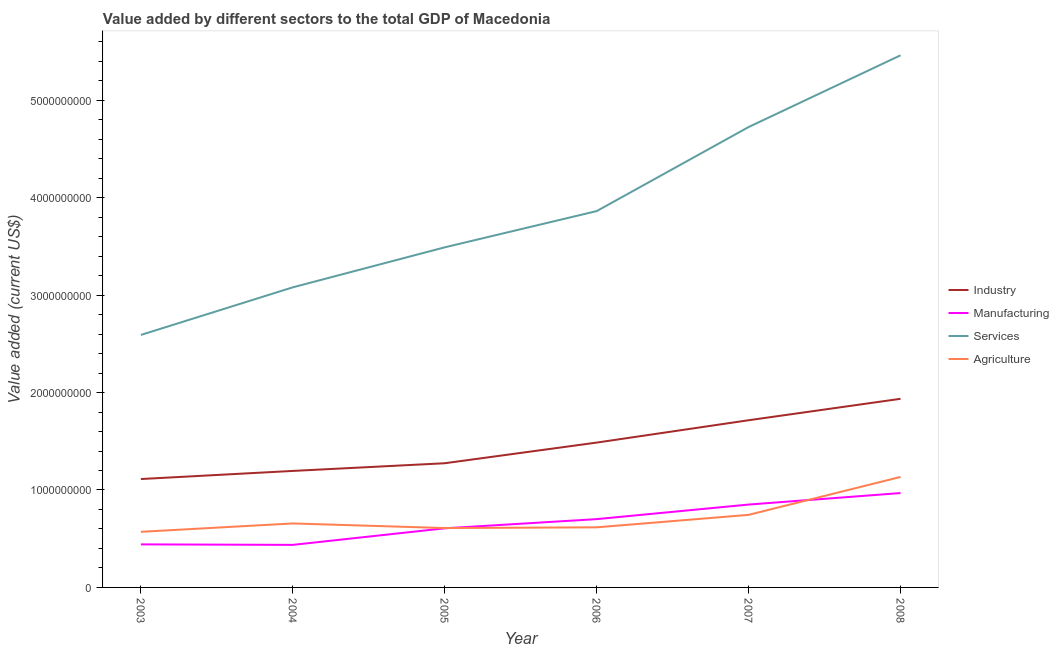How many different coloured lines are there?
Your answer should be compact. 4. Does the line corresponding to value added by agricultural sector intersect with the line corresponding to value added by industrial sector?
Your response must be concise. No. Is the number of lines equal to the number of legend labels?
Offer a very short reply. Yes. What is the value added by services sector in 2006?
Ensure brevity in your answer.  3.86e+09. Across all years, what is the maximum value added by industrial sector?
Provide a short and direct response. 1.94e+09. Across all years, what is the minimum value added by manufacturing sector?
Give a very brief answer. 4.37e+08. In which year was the value added by services sector maximum?
Offer a terse response. 2008. In which year was the value added by services sector minimum?
Make the answer very short. 2003. What is the total value added by services sector in the graph?
Give a very brief answer. 2.32e+1. What is the difference between the value added by services sector in 2007 and that in 2008?
Ensure brevity in your answer.  -7.36e+08. What is the difference between the value added by services sector in 2005 and the value added by manufacturing sector in 2003?
Offer a very short reply. 3.05e+09. What is the average value added by agricultural sector per year?
Your response must be concise. 7.22e+08. In the year 2004, what is the difference between the value added by manufacturing sector and value added by agricultural sector?
Your response must be concise. -2.20e+08. In how many years, is the value added by manufacturing sector greater than 600000000 US$?
Offer a terse response. 4. What is the ratio of the value added by manufacturing sector in 2004 to that in 2005?
Give a very brief answer. 0.72. Is the value added by industrial sector in 2006 less than that in 2008?
Make the answer very short. Yes. Is the difference between the value added by industrial sector in 2003 and 2007 greater than the difference between the value added by agricultural sector in 2003 and 2007?
Give a very brief answer. No. What is the difference between the highest and the second highest value added by agricultural sector?
Your answer should be very brief. 3.89e+08. What is the difference between the highest and the lowest value added by agricultural sector?
Keep it short and to the point. 5.63e+08. Is the sum of the value added by manufacturing sector in 2003 and 2008 greater than the maximum value added by services sector across all years?
Offer a terse response. No. Is it the case that in every year, the sum of the value added by industrial sector and value added by manufacturing sector is greater than the sum of value added by services sector and value added by agricultural sector?
Offer a terse response. Yes. Is it the case that in every year, the sum of the value added by industrial sector and value added by manufacturing sector is greater than the value added by services sector?
Provide a short and direct response. No. Is the value added by services sector strictly greater than the value added by agricultural sector over the years?
Your response must be concise. Yes. Is the value added by services sector strictly less than the value added by agricultural sector over the years?
Your answer should be very brief. No. How many lines are there?
Give a very brief answer. 4. Are the values on the major ticks of Y-axis written in scientific E-notation?
Give a very brief answer. No. What is the title of the graph?
Offer a very short reply. Value added by different sectors to the total GDP of Macedonia. Does "Tracking ability" appear as one of the legend labels in the graph?
Your answer should be compact. No. What is the label or title of the X-axis?
Provide a succinct answer. Year. What is the label or title of the Y-axis?
Your answer should be compact. Value added (current US$). What is the Value added (current US$) in Industry in 2003?
Your answer should be compact. 1.11e+09. What is the Value added (current US$) in Manufacturing in 2003?
Your answer should be very brief. 4.42e+08. What is the Value added (current US$) in Services in 2003?
Your response must be concise. 2.59e+09. What is the Value added (current US$) in Agriculture in 2003?
Give a very brief answer. 5.71e+08. What is the Value added (current US$) of Industry in 2004?
Give a very brief answer. 1.20e+09. What is the Value added (current US$) of Manufacturing in 2004?
Your response must be concise. 4.37e+08. What is the Value added (current US$) of Services in 2004?
Your answer should be compact. 3.08e+09. What is the Value added (current US$) in Agriculture in 2004?
Give a very brief answer. 6.57e+08. What is the Value added (current US$) in Industry in 2005?
Ensure brevity in your answer.  1.27e+09. What is the Value added (current US$) in Manufacturing in 2005?
Your response must be concise. 6.07e+08. What is the Value added (current US$) of Services in 2005?
Provide a short and direct response. 3.49e+09. What is the Value added (current US$) in Agriculture in 2005?
Make the answer very short. 6.09e+08. What is the Value added (current US$) of Industry in 2006?
Your answer should be compact. 1.49e+09. What is the Value added (current US$) of Manufacturing in 2006?
Provide a short and direct response. 7.01e+08. What is the Value added (current US$) in Services in 2006?
Make the answer very short. 3.86e+09. What is the Value added (current US$) of Agriculture in 2006?
Offer a very short reply. 6.17e+08. What is the Value added (current US$) in Industry in 2007?
Provide a succinct answer. 1.72e+09. What is the Value added (current US$) in Manufacturing in 2007?
Ensure brevity in your answer.  8.50e+08. What is the Value added (current US$) in Services in 2007?
Offer a very short reply. 4.72e+09. What is the Value added (current US$) of Agriculture in 2007?
Keep it short and to the point. 7.45e+08. What is the Value added (current US$) in Industry in 2008?
Your response must be concise. 1.94e+09. What is the Value added (current US$) of Manufacturing in 2008?
Provide a succinct answer. 9.68e+08. What is the Value added (current US$) in Services in 2008?
Ensure brevity in your answer.  5.46e+09. What is the Value added (current US$) in Agriculture in 2008?
Offer a terse response. 1.13e+09. Across all years, what is the maximum Value added (current US$) in Industry?
Provide a succinct answer. 1.94e+09. Across all years, what is the maximum Value added (current US$) in Manufacturing?
Keep it short and to the point. 9.68e+08. Across all years, what is the maximum Value added (current US$) of Services?
Offer a very short reply. 5.46e+09. Across all years, what is the maximum Value added (current US$) of Agriculture?
Provide a short and direct response. 1.13e+09. Across all years, what is the minimum Value added (current US$) of Industry?
Your answer should be compact. 1.11e+09. Across all years, what is the minimum Value added (current US$) of Manufacturing?
Provide a short and direct response. 4.37e+08. Across all years, what is the minimum Value added (current US$) of Services?
Keep it short and to the point. 2.59e+09. Across all years, what is the minimum Value added (current US$) in Agriculture?
Give a very brief answer. 5.71e+08. What is the total Value added (current US$) in Industry in the graph?
Give a very brief answer. 8.72e+09. What is the total Value added (current US$) of Manufacturing in the graph?
Offer a terse response. 4.00e+09. What is the total Value added (current US$) in Services in the graph?
Provide a succinct answer. 2.32e+1. What is the total Value added (current US$) of Agriculture in the graph?
Provide a succinct answer. 4.33e+09. What is the difference between the Value added (current US$) in Industry in 2003 and that in 2004?
Offer a terse response. -8.32e+07. What is the difference between the Value added (current US$) of Manufacturing in 2003 and that in 2004?
Keep it short and to the point. 5.04e+06. What is the difference between the Value added (current US$) in Services in 2003 and that in 2004?
Ensure brevity in your answer.  -4.89e+08. What is the difference between the Value added (current US$) of Agriculture in 2003 and that in 2004?
Offer a very short reply. -8.59e+07. What is the difference between the Value added (current US$) of Industry in 2003 and that in 2005?
Ensure brevity in your answer.  -1.62e+08. What is the difference between the Value added (current US$) in Manufacturing in 2003 and that in 2005?
Ensure brevity in your answer.  -1.65e+08. What is the difference between the Value added (current US$) in Services in 2003 and that in 2005?
Make the answer very short. -8.99e+08. What is the difference between the Value added (current US$) of Agriculture in 2003 and that in 2005?
Your answer should be compact. -3.86e+07. What is the difference between the Value added (current US$) of Industry in 2003 and that in 2006?
Your answer should be very brief. -3.74e+08. What is the difference between the Value added (current US$) in Manufacturing in 2003 and that in 2006?
Your answer should be very brief. -2.59e+08. What is the difference between the Value added (current US$) in Services in 2003 and that in 2006?
Give a very brief answer. -1.27e+09. What is the difference between the Value added (current US$) in Agriculture in 2003 and that in 2006?
Provide a succinct answer. -4.61e+07. What is the difference between the Value added (current US$) in Industry in 2003 and that in 2007?
Your response must be concise. -6.03e+08. What is the difference between the Value added (current US$) in Manufacturing in 2003 and that in 2007?
Offer a very short reply. -4.09e+08. What is the difference between the Value added (current US$) in Services in 2003 and that in 2007?
Keep it short and to the point. -2.13e+09. What is the difference between the Value added (current US$) in Agriculture in 2003 and that in 2007?
Give a very brief answer. -1.74e+08. What is the difference between the Value added (current US$) of Industry in 2003 and that in 2008?
Offer a very short reply. -8.23e+08. What is the difference between the Value added (current US$) in Manufacturing in 2003 and that in 2008?
Your response must be concise. -5.27e+08. What is the difference between the Value added (current US$) of Services in 2003 and that in 2008?
Your response must be concise. -2.87e+09. What is the difference between the Value added (current US$) of Agriculture in 2003 and that in 2008?
Your answer should be compact. -5.63e+08. What is the difference between the Value added (current US$) in Industry in 2004 and that in 2005?
Keep it short and to the point. -7.88e+07. What is the difference between the Value added (current US$) in Manufacturing in 2004 and that in 2005?
Provide a short and direct response. -1.70e+08. What is the difference between the Value added (current US$) in Services in 2004 and that in 2005?
Give a very brief answer. -4.11e+08. What is the difference between the Value added (current US$) of Agriculture in 2004 and that in 2005?
Your answer should be compact. 4.72e+07. What is the difference between the Value added (current US$) of Industry in 2004 and that in 2006?
Ensure brevity in your answer.  -2.91e+08. What is the difference between the Value added (current US$) of Manufacturing in 2004 and that in 2006?
Ensure brevity in your answer.  -2.64e+08. What is the difference between the Value added (current US$) in Services in 2004 and that in 2006?
Make the answer very short. -7.82e+08. What is the difference between the Value added (current US$) in Agriculture in 2004 and that in 2006?
Your answer should be very brief. 3.98e+07. What is the difference between the Value added (current US$) of Industry in 2004 and that in 2007?
Give a very brief answer. -5.20e+08. What is the difference between the Value added (current US$) in Manufacturing in 2004 and that in 2007?
Ensure brevity in your answer.  -4.14e+08. What is the difference between the Value added (current US$) in Services in 2004 and that in 2007?
Keep it short and to the point. -1.64e+09. What is the difference between the Value added (current US$) of Agriculture in 2004 and that in 2007?
Give a very brief answer. -8.81e+07. What is the difference between the Value added (current US$) in Industry in 2004 and that in 2008?
Keep it short and to the point. -7.40e+08. What is the difference between the Value added (current US$) in Manufacturing in 2004 and that in 2008?
Offer a very short reply. -5.32e+08. What is the difference between the Value added (current US$) of Services in 2004 and that in 2008?
Offer a very short reply. -2.38e+09. What is the difference between the Value added (current US$) in Agriculture in 2004 and that in 2008?
Offer a terse response. -4.77e+08. What is the difference between the Value added (current US$) of Industry in 2005 and that in 2006?
Make the answer very short. -2.12e+08. What is the difference between the Value added (current US$) in Manufacturing in 2005 and that in 2006?
Provide a succinct answer. -9.43e+07. What is the difference between the Value added (current US$) of Services in 2005 and that in 2006?
Offer a terse response. -3.72e+08. What is the difference between the Value added (current US$) in Agriculture in 2005 and that in 2006?
Provide a short and direct response. -7.43e+06. What is the difference between the Value added (current US$) of Industry in 2005 and that in 2007?
Offer a terse response. -4.41e+08. What is the difference between the Value added (current US$) of Manufacturing in 2005 and that in 2007?
Offer a very short reply. -2.44e+08. What is the difference between the Value added (current US$) in Services in 2005 and that in 2007?
Provide a succinct answer. -1.23e+09. What is the difference between the Value added (current US$) in Agriculture in 2005 and that in 2007?
Keep it short and to the point. -1.35e+08. What is the difference between the Value added (current US$) in Industry in 2005 and that in 2008?
Your answer should be compact. -6.61e+08. What is the difference between the Value added (current US$) of Manufacturing in 2005 and that in 2008?
Your answer should be very brief. -3.62e+08. What is the difference between the Value added (current US$) of Services in 2005 and that in 2008?
Your answer should be compact. -1.97e+09. What is the difference between the Value added (current US$) of Agriculture in 2005 and that in 2008?
Offer a terse response. -5.25e+08. What is the difference between the Value added (current US$) in Industry in 2006 and that in 2007?
Provide a short and direct response. -2.29e+08. What is the difference between the Value added (current US$) of Manufacturing in 2006 and that in 2007?
Keep it short and to the point. -1.49e+08. What is the difference between the Value added (current US$) of Services in 2006 and that in 2007?
Offer a terse response. -8.63e+08. What is the difference between the Value added (current US$) of Agriculture in 2006 and that in 2007?
Give a very brief answer. -1.28e+08. What is the difference between the Value added (current US$) in Industry in 2006 and that in 2008?
Keep it short and to the point. -4.49e+08. What is the difference between the Value added (current US$) of Manufacturing in 2006 and that in 2008?
Offer a terse response. -2.67e+08. What is the difference between the Value added (current US$) of Services in 2006 and that in 2008?
Keep it short and to the point. -1.60e+09. What is the difference between the Value added (current US$) of Agriculture in 2006 and that in 2008?
Ensure brevity in your answer.  -5.17e+08. What is the difference between the Value added (current US$) of Industry in 2007 and that in 2008?
Provide a succinct answer. -2.20e+08. What is the difference between the Value added (current US$) of Manufacturing in 2007 and that in 2008?
Offer a terse response. -1.18e+08. What is the difference between the Value added (current US$) in Services in 2007 and that in 2008?
Give a very brief answer. -7.36e+08. What is the difference between the Value added (current US$) of Agriculture in 2007 and that in 2008?
Your response must be concise. -3.89e+08. What is the difference between the Value added (current US$) in Industry in 2003 and the Value added (current US$) in Manufacturing in 2004?
Offer a terse response. 6.76e+08. What is the difference between the Value added (current US$) in Industry in 2003 and the Value added (current US$) in Services in 2004?
Ensure brevity in your answer.  -1.97e+09. What is the difference between the Value added (current US$) of Industry in 2003 and the Value added (current US$) of Agriculture in 2004?
Your answer should be compact. 4.56e+08. What is the difference between the Value added (current US$) in Manufacturing in 2003 and the Value added (current US$) in Services in 2004?
Ensure brevity in your answer.  -2.64e+09. What is the difference between the Value added (current US$) in Manufacturing in 2003 and the Value added (current US$) in Agriculture in 2004?
Your response must be concise. -2.15e+08. What is the difference between the Value added (current US$) in Services in 2003 and the Value added (current US$) in Agriculture in 2004?
Your answer should be very brief. 1.93e+09. What is the difference between the Value added (current US$) of Industry in 2003 and the Value added (current US$) of Manufacturing in 2005?
Make the answer very short. 5.06e+08. What is the difference between the Value added (current US$) in Industry in 2003 and the Value added (current US$) in Services in 2005?
Offer a very short reply. -2.38e+09. What is the difference between the Value added (current US$) in Industry in 2003 and the Value added (current US$) in Agriculture in 2005?
Offer a very short reply. 5.03e+08. What is the difference between the Value added (current US$) of Manufacturing in 2003 and the Value added (current US$) of Services in 2005?
Provide a short and direct response. -3.05e+09. What is the difference between the Value added (current US$) of Manufacturing in 2003 and the Value added (current US$) of Agriculture in 2005?
Give a very brief answer. -1.68e+08. What is the difference between the Value added (current US$) in Services in 2003 and the Value added (current US$) in Agriculture in 2005?
Provide a succinct answer. 1.98e+09. What is the difference between the Value added (current US$) in Industry in 2003 and the Value added (current US$) in Manufacturing in 2006?
Your answer should be compact. 4.11e+08. What is the difference between the Value added (current US$) in Industry in 2003 and the Value added (current US$) in Services in 2006?
Your response must be concise. -2.75e+09. What is the difference between the Value added (current US$) in Industry in 2003 and the Value added (current US$) in Agriculture in 2006?
Provide a succinct answer. 4.96e+08. What is the difference between the Value added (current US$) of Manufacturing in 2003 and the Value added (current US$) of Services in 2006?
Your answer should be very brief. -3.42e+09. What is the difference between the Value added (current US$) in Manufacturing in 2003 and the Value added (current US$) in Agriculture in 2006?
Keep it short and to the point. -1.75e+08. What is the difference between the Value added (current US$) in Services in 2003 and the Value added (current US$) in Agriculture in 2006?
Make the answer very short. 1.97e+09. What is the difference between the Value added (current US$) in Industry in 2003 and the Value added (current US$) in Manufacturing in 2007?
Provide a succinct answer. 2.62e+08. What is the difference between the Value added (current US$) of Industry in 2003 and the Value added (current US$) of Services in 2007?
Your response must be concise. -3.61e+09. What is the difference between the Value added (current US$) in Industry in 2003 and the Value added (current US$) in Agriculture in 2007?
Provide a short and direct response. 3.68e+08. What is the difference between the Value added (current US$) in Manufacturing in 2003 and the Value added (current US$) in Services in 2007?
Offer a terse response. -4.28e+09. What is the difference between the Value added (current US$) in Manufacturing in 2003 and the Value added (current US$) in Agriculture in 2007?
Make the answer very short. -3.03e+08. What is the difference between the Value added (current US$) of Services in 2003 and the Value added (current US$) of Agriculture in 2007?
Offer a terse response. 1.85e+09. What is the difference between the Value added (current US$) in Industry in 2003 and the Value added (current US$) in Manufacturing in 2008?
Offer a very short reply. 1.44e+08. What is the difference between the Value added (current US$) of Industry in 2003 and the Value added (current US$) of Services in 2008?
Your response must be concise. -4.35e+09. What is the difference between the Value added (current US$) of Industry in 2003 and the Value added (current US$) of Agriculture in 2008?
Provide a short and direct response. -2.16e+07. What is the difference between the Value added (current US$) in Manufacturing in 2003 and the Value added (current US$) in Services in 2008?
Provide a short and direct response. -5.02e+09. What is the difference between the Value added (current US$) in Manufacturing in 2003 and the Value added (current US$) in Agriculture in 2008?
Your answer should be compact. -6.92e+08. What is the difference between the Value added (current US$) in Services in 2003 and the Value added (current US$) in Agriculture in 2008?
Offer a very short reply. 1.46e+09. What is the difference between the Value added (current US$) of Industry in 2004 and the Value added (current US$) of Manufacturing in 2005?
Give a very brief answer. 5.89e+08. What is the difference between the Value added (current US$) in Industry in 2004 and the Value added (current US$) in Services in 2005?
Offer a very short reply. -2.29e+09. What is the difference between the Value added (current US$) in Industry in 2004 and the Value added (current US$) in Agriculture in 2005?
Make the answer very short. 5.86e+08. What is the difference between the Value added (current US$) of Manufacturing in 2004 and the Value added (current US$) of Services in 2005?
Offer a very short reply. -3.05e+09. What is the difference between the Value added (current US$) of Manufacturing in 2004 and the Value added (current US$) of Agriculture in 2005?
Your answer should be compact. -1.73e+08. What is the difference between the Value added (current US$) in Services in 2004 and the Value added (current US$) in Agriculture in 2005?
Give a very brief answer. 2.47e+09. What is the difference between the Value added (current US$) in Industry in 2004 and the Value added (current US$) in Manufacturing in 2006?
Offer a very short reply. 4.95e+08. What is the difference between the Value added (current US$) of Industry in 2004 and the Value added (current US$) of Services in 2006?
Offer a very short reply. -2.67e+09. What is the difference between the Value added (current US$) in Industry in 2004 and the Value added (current US$) in Agriculture in 2006?
Your answer should be compact. 5.79e+08. What is the difference between the Value added (current US$) of Manufacturing in 2004 and the Value added (current US$) of Services in 2006?
Provide a succinct answer. -3.43e+09. What is the difference between the Value added (current US$) of Manufacturing in 2004 and the Value added (current US$) of Agriculture in 2006?
Offer a terse response. -1.80e+08. What is the difference between the Value added (current US$) in Services in 2004 and the Value added (current US$) in Agriculture in 2006?
Give a very brief answer. 2.46e+09. What is the difference between the Value added (current US$) in Industry in 2004 and the Value added (current US$) in Manufacturing in 2007?
Provide a succinct answer. 3.45e+08. What is the difference between the Value added (current US$) of Industry in 2004 and the Value added (current US$) of Services in 2007?
Provide a short and direct response. -3.53e+09. What is the difference between the Value added (current US$) of Industry in 2004 and the Value added (current US$) of Agriculture in 2007?
Your answer should be very brief. 4.51e+08. What is the difference between the Value added (current US$) in Manufacturing in 2004 and the Value added (current US$) in Services in 2007?
Give a very brief answer. -4.29e+09. What is the difference between the Value added (current US$) of Manufacturing in 2004 and the Value added (current US$) of Agriculture in 2007?
Ensure brevity in your answer.  -3.08e+08. What is the difference between the Value added (current US$) in Services in 2004 and the Value added (current US$) in Agriculture in 2007?
Your answer should be very brief. 2.34e+09. What is the difference between the Value added (current US$) of Industry in 2004 and the Value added (current US$) of Manufacturing in 2008?
Ensure brevity in your answer.  2.27e+08. What is the difference between the Value added (current US$) of Industry in 2004 and the Value added (current US$) of Services in 2008?
Offer a terse response. -4.27e+09. What is the difference between the Value added (current US$) of Industry in 2004 and the Value added (current US$) of Agriculture in 2008?
Provide a succinct answer. 6.16e+07. What is the difference between the Value added (current US$) in Manufacturing in 2004 and the Value added (current US$) in Services in 2008?
Offer a very short reply. -5.02e+09. What is the difference between the Value added (current US$) of Manufacturing in 2004 and the Value added (current US$) of Agriculture in 2008?
Your answer should be compact. -6.97e+08. What is the difference between the Value added (current US$) of Services in 2004 and the Value added (current US$) of Agriculture in 2008?
Offer a very short reply. 1.95e+09. What is the difference between the Value added (current US$) of Industry in 2005 and the Value added (current US$) of Manufacturing in 2006?
Provide a succinct answer. 5.73e+08. What is the difference between the Value added (current US$) of Industry in 2005 and the Value added (current US$) of Services in 2006?
Your answer should be very brief. -2.59e+09. What is the difference between the Value added (current US$) in Industry in 2005 and the Value added (current US$) in Agriculture in 2006?
Offer a very short reply. 6.58e+08. What is the difference between the Value added (current US$) in Manufacturing in 2005 and the Value added (current US$) in Services in 2006?
Ensure brevity in your answer.  -3.26e+09. What is the difference between the Value added (current US$) in Manufacturing in 2005 and the Value added (current US$) in Agriculture in 2006?
Make the answer very short. -1.01e+07. What is the difference between the Value added (current US$) of Services in 2005 and the Value added (current US$) of Agriculture in 2006?
Give a very brief answer. 2.87e+09. What is the difference between the Value added (current US$) in Industry in 2005 and the Value added (current US$) in Manufacturing in 2007?
Provide a short and direct response. 4.24e+08. What is the difference between the Value added (current US$) in Industry in 2005 and the Value added (current US$) in Services in 2007?
Give a very brief answer. -3.45e+09. What is the difference between the Value added (current US$) in Industry in 2005 and the Value added (current US$) in Agriculture in 2007?
Offer a terse response. 5.30e+08. What is the difference between the Value added (current US$) in Manufacturing in 2005 and the Value added (current US$) in Services in 2007?
Provide a short and direct response. -4.12e+09. What is the difference between the Value added (current US$) of Manufacturing in 2005 and the Value added (current US$) of Agriculture in 2007?
Make the answer very short. -1.38e+08. What is the difference between the Value added (current US$) in Services in 2005 and the Value added (current US$) in Agriculture in 2007?
Give a very brief answer. 2.75e+09. What is the difference between the Value added (current US$) of Industry in 2005 and the Value added (current US$) of Manufacturing in 2008?
Your response must be concise. 3.06e+08. What is the difference between the Value added (current US$) of Industry in 2005 and the Value added (current US$) of Services in 2008?
Give a very brief answer. -4.19e+09. What is the difference between the Value added (current US$) of Industry in 2005 and the Value added (current US$) of Agriculture in 2008?
Your answer should be compact. 1.40e+08. What is the difference between the Value added (current US$) in Manufacturing in 2005 and the Value added (current US$) in Services in 2008?
Give a very brief answer. -4.85e+09. What is the difference between the Value added (current US$) in Manufacturing in 2005 and the Value added (current US$) in Agriculture in 2008?
Make the answer very short. -5.27e+08. What is the difference between the Value added (current US$) in Services in 2005 and the Value added (current US$) in Agriculture in 2008?
Your response must be concise. 2.36e+09. What is the difference between the Value added (current US$) of Industry in 2006 and the Value added (current US$) of Manufacturing in 2007?
Provide a succinct answer. 6.36e+08. What is the difference between the Value added (current US$) of Industry in 2006 and the Value added (current US$) of Services in 2007?
Give a very brief answer. -3.24e+09. What is the difference between the Value added (current US$) in Industry in 2006 and the Value added (current US$) in Agriculture in 2007?
Provide a short and direct response. 7.42e+08. What is the difference between the Value added (current US$) of Manufacturing in 2006 and the Value added (current US$) of Services in 2007?
Your answer should be compact. -4.02e+09. What is the difference between the Value added (current US$) of Manufacturing in 2006 and the Value added (current US$) of Agriculture in 2007?
Offer a terse response. -4.37e+07. What is the difference between the Value added (current US$) in Services in 2006 and the Value added (current US$) in Agriculture in 2007?
Your answer should be very brief. 3.12e+09. What is the difference between the Value added (current US$) of Industry in 2006 and the Value added (current US$) of Manufacturing in 2008?
Ensure brevity in your answer.  5.18e+08. What is the difference between the Value added (current US$) in Industry in 2006 and the Value added (current US$) in Services in 2008?
Provide a short and direct response. -3.97e+09. What is the difference between the Value added (current US$) in Industry in 2006 and the Value added (current US$) in Agriculture in 2008?
Offer a terse response. 3.52e+08. What is the difference between the Value added (current US$) of Manufacturing in 2006 and the Value added (current US$) of Services in 2008?
Make the answer very short. -4.76e+09. What is the difference between the Value added (current US$) of Manufacturing in 2006 and the Value added (current US$) of Agriculture in 2008?
Give a very brief answer. -4.33e+08. What is the difference between the Value added (current US$) in Services in 2006 and the Value added (current US$) in Agriculture in 2008?
Your answer should be very brief. 2.73e+09. What is the difference between the Value added (current US$) in Industry in 2007 and the Value added (current US$) in Manufacturing in 2008?
Provide a succinct answer. 7.47e+08. What is the difference between the Value added (current US$) of Industry in 2007 and the Value added (current US$) of Services in 2008?
Offer a terse response. -3.75e+09. What is the difference between the Value added (current US$) of Industry in 2007 and the Value added (current US$) of Agriculture in 2008?
Your answer should be very brief. 5.82e+08. What is the difference between the Value added (current US$) of Manufacturing in 2007 and the Value added (current US$) of Services in 2008?
Keep it short and to the point. -4.61e+09. What is the difference between the Value added (current US$) in Manufacturing in 2007 and the Value added (current US$) in Agriculture in 2008?
Ensure brevity in your answer.  -2.84e+08. What is the difference between the Value added (current US$) of Services in 2007 and the Value added (current US$) of Agriculture in 2008?
Keep it short and to the point. 3.59e+09. What is the average Value added (current US$) in Industry per year?
Make the answer very short. 1.45e+09. What is the average Value added (current US$) of Manufacturing per year?
Keep it short and to the point. 6.67e+08. What is the average Value added (current US$) of Services per year?
Make the answer very short. 3.87e+09. What is the average Value added (current US$) of Agriculture per year?
Your answer should be very brief. 7.22e+08. In the year 2003, what is the difference between the Value added (current US$) of Industry and Value added (current US$) of Manufacturing?
Your answer should be compact. 6.71e+08. In the year 2003, what is the difference between the Value added (current US$) in Industry and Value added (current US$) in Services?
Your answer should be compact. -1.48e+09. In the year 2003, what is the difference between the Value added (current US$) in Industry and Value added (current US$) in Agriculture?
Your answer should be very brief. 5.42e+08. In the year 2003, what is the difference between the Value added (current US$) in Manufacturing and Value added (current US$) in Services?
Your answer should be compact. -2.15e+09. In the year 2003, what is the difference between the Value added (current US$) of Manufacturing and Value added (current US$) of Agriculture?
Your answer should be compact. -1.29e+08. In the year 2003, what is the difference between the Value added (current US$) of Services and Value added (current US$) of Agriculture?
Your response must be concise. 2.02e+09. In the year 2004, what is the difference between the Value added (current US$) of Industry and Value added (current US$) of Manufacturing?
Your answer should be compact. 7.59e+08. In the year 2004, what is the difference between the Value added (current US$) of Industry and Value added (current US$) of Services?
Provide a succinct answer. -1.88e+09. In the year 2004, what is the difference between the Value added (current US$) of Industry and Value added (current US$) of Agriculture?
Offer a terse response. 5.39e+08. In the year 2004, what is the difference between the Value added (current US$) in Manufacturing and Value added (current US$) in Services?
Ensure brevity in your answer.  -2.64e+09. In the year 2004, what is the difference between the Value added (current US$) in Manufacturing and Value added (current US$) in Agriculture?
Give a very brief answer. -2.20e+08. In the year 2004, what is the difference between the Value added (current US$) in Services and Value added (current US$) in Agriculture?
Make the answer very short. 2.42e+09. In the year 2005, what is the difference between the Value added (current US$) of Industry and Value added (current US$) of Manufacturing?
Provide a succinct answer. 6.68e+08. In the year 2005, what is the difference between the Value added (current US$) of Industry and Value added (current US$) of Services?
Your response must be concise. -2.22e+09. In the year 2005, what is the difference between the Value added (current US$) of Industry and Value added (current US$) of Agriculture?
Your response must be concise. 6.65e+08. In the year 2005, what is the difference between the Value added (current US$) of Manufacturing and Value added (current US$) of Services?
Make the answer very short. -2.88e+09. In the year 2005, what is the difference between the Value added (current US$) in Manufacturing and Value added (current US$) in Agriculture?
Ensure brevity in your answer.  -2.68e+06. In the year 2005, what is the difference between the Value added (current US$) in Services and Value added (current US$) in Agriculture?
Make the answer very short. 2.88e+09. In the year 2006, what is the difference between the Value added (current US$) of Industry and Value added (current US$) of Manufacturing?
Ensure brevity in your answer.  7.85e+08. In the year 2006, what is the difference between the Value added (current US$) in Industry and Value added (current US$) in Services?
Offer a very short reply. -2.38e+09. In the year 2006, what is the difference between the Value added (current US$) in Industry and Value added (current US$) in Agriculture?
Your answer should be very brief. 8.70e+08. In the year 2006, what is the difference between the Value added (current US$) of Manufacturing and Value added (current US$) of Services?
Make the answer very short. -3.16e+09. In the year 2006, what is the difference between the Value added (current US$) in Manufacturing and Value added (current US$) in Agriculture?
Your response must be concise. 8.42e+07. In the year 2006, what is the difference between the Value added (current US$) of Services and Value added (current US$) of Agriculture?
Ensure brevity in your answer.  3.25e+09. In the year 2007, what is the difference between the Value added (current US$) in Industry and Value added (current US$) in Manufacturing?
Ensure brevity in your answer.  8.65e+08. In the year 2007, what is the difference between the Value added (current US$) in Industry and Value added (current US$) in Services?
Offer a very short reply. -3.01e+09. In the year 2007, what is the difference between the Value added (current US$) in Industry and Value added (current US$) in Agriculture?
Provide a short and direct response. 9.71e+08. In the year 2007, what is the difference between the Value added (current US$) in Manufacturing and Value added (current US$) in Services?
Your answer should be very brief. -3.87e+09. In the year 2007, what is the difference between the Value added (current US$) of Manufacturing and Value added (current US$) of Agriculture?
Ensure brevity in your answer.  1.06e+08. In the year 2007, what is the difference between the Value added (current US$) in Services and Value added (current US$) in Agriculture?
Keep it short and to the point. 3.98e+09. In the year 2008, what is the difference between the Value added (current US$) in Industry and Value added (current US$) in Manufacturing?
Provide a short and direct response. 9.67e+08. In the year 2008, what is the difference between the Value added (current US$) of Industry and Value added (current US$) of Services?
Offer a very short reply. -3.53e+09. In the year 2008, what is the difference between the Value added (current US$) of Industry and Value added (current US$) of Agriculture?
Offer a very short reply. 8.02e+08. In the year 2008, what is the difference between the Value added (current US$) of Manufacturing and Value added (current US$) of Services?
Your response must be concise. -4.49e+09. In the year 2008, what is the difference between the Value added (current US$) in Manufacturing and Value added (current US$) in Agriculture?
Keep it short and to the point. -1.66e+08. In the year 2008, what is the difference between the Value added (current US$) in Services and Value added (current US$) in Agriculture?
Ensure brevity in your answer.  4.33e+09. What is the ratio of the Value added (current US$) of Industry in 2003 to that in 2004?
Offer a terse response. 0.93. What is the ratio of the Value added (current US$) of Manufacturing in 2003 to that in 2004?
Give a very brief answer. 1.01. What is the ratio of the Value added (current US$) of Services in 2003 to that in 2004?
Make the answer very short. 0.84. What is the ratio of the Value added (current US$) of Agriculture in 2003 to that in 2004?
Keep it short and to the point. 0.87. What is the ratio of the Value added (current US$) of Industry in 2003 to that in 2005?
Your answer should be compact. 0.87. What is the ratio of the Value added (current US$) of Manufacturing in 2003 to that in 2005?
Give a very brief answer. 0.73. What is the ratio of the Value added (current US$) of Services in 2003 to that in 2005?
Your answer should be very brief. 0.74. What is the ratio of the Value added (current US$) of Agriculture in 2003 to that in 2005?
Provide a succinct answer. 0.94. What is the ratio of the Value added (current US$) in Industry in 2003 to that in 2006?
Provide a short and direct response. 0.75. What is the ratio of the Value added (current US$) of Manufacturing in 2003 to that in 2006?
Ensure brevity in your answer.  0.63. What is the ratio of the Value added (current US$) in Services in 2003 to that in 2006?
Ensure brevity in your answer.  0.67. What is the ratio of the Value added (current US$) in Agriculture in 2003 to that in 2006?
Make the answer very short. 0.93. What is the ratio of the Value added (current US$) in Industry in 2003 to that in 2007?
Offer a terse response. 0.65. What is the ratio of the Value added (current US$) of Manufacturing in 2003 to that in 2007?
Your response must be concise. 0.52. What is the ratio of the Value added (current US$) in Services in 2003 to that in 2007?
Your answer should be compact. 0.55. What is the ratio of the Value added (current US$) of Agriculture in 2003 to that in 2007?
Your response must be concise. 0.77. What is the ratio of the Value added (current US$) in Industry in 2003 to that in 2008?
Provide a succinct answer. 0.57. What is the ratio of the Value added (current US$) in Manufacturing in 2003 to that in 2008?
Provide a succinct answer. 0.46. What is the ratio of the Value added (current US$) in Services in 2003 to that in 2008?
Ensure brevity in your answer.  0.47. What is the ratio of the Value added (current US$) in Agriculture in 2003 to that in 2008?
Your answer should be very brief. 0.5. What is the ratio of the Value added (current US$) in Industry in 2004 to that in 2005?
Your response must be concise. 0.94. What is the ratio of the Value added (current US$) in Manufacturing in 2004 to that in 2005?
Your response must be concise. 0.72. What is the ratio of the Value added (current US$) of Services in 2004 to that in 2005?
Your answer should be very brief. 0.88. What is the ratio of the Value added (current US$) in Agriculture in 2004 to that in 2005?
Ensure brevity in your answer.  1.08. What is the ratio of the Value added (current US$) of Industry in 2004 to that in 2006?
Provide a short and direct response. 0.8. What is the ratio of the Value added (current US$) in Manufacturing in 2004 to that in 2006?
Offer a very short reply. 0.62. What is the ratio of the Value added (current US$) of Services in 2004 to that in 2006?
Your answer should be very brief. 0.8. What is the ratio of the Value added (current US$) in Agriculture in 2004 to that in 2006?
Your answer should be very brief. 1.06. What is the ratio of the Value added (current US$) of Industry in 2004 to that in 2007?
Offer a terse response. 0.7. What is the ratio of the Value added (current US$) in Manufacturing in 2004 to that in 2007?
Make the answer very short. 0.51. What is the ratio of the Value added (current US$) of Services in 2004 to that in 2007?
Your response must be concise. 0.65. What is the ratio of the Value added (current US$) of Agriculture in 2004 to that in 2007?
Give a very brief answer. 0.88. What is the ratio of the Value added (current US$) of Industry in 2004 to that in 2008?
Keep it short and to the point. 0.62. What is the ratio of the Value added (current US$) of Manufacturing in 2004 to that in 2008?
Your answer should be very brief. 0.45. What is the ratio of the Value added (current US$) in Services in 2004 to that in 2008?
Keep it short and to the point. 0.56. What is the ratio of the Value added (current US$) in Agriculture in 2004 to that in 2008?
Your response must be concise. 0.58. What is the ratio of the Value added (current US$) in Industry in 2005 to that in 2006?
Your answer should be very brief. 0.86. What is the ratio of the Value added (current US$) of Manufacturing in 2005 to that in 2006?
Make the answer very short. 0.87. What is the ratio of the Value added (current US$) of Services in 2005 to that in 2006?
Ensure brevity in your answer.  0.9. What is the ratio of the Value added (current US$) of Agriculture in 2005 to that in 2006?
Your answer should be compact. 0.99. What is the ratio of the Value added (current US$) in Industry in 2005 to that in 2007?
Keep it short and to the point. 0.74. What is the ratio of the Value added (current US$) of Manufacturing in 2005 to that in 2007?
Your response must be concise. 0.71. What is the ratio of the Value added (current US$) of Services in 2005 to that in 2007?
Offer a terse response. 0.74. What is the ratio of the Value added (current US$) of Agriculture in 2005 to that in 2007?
Make the answer very short. 0.82. What is the ratio of the Value added (current US$) in Industry in 2005 to that in 2008?
Your answer should be compact. 0.66. What is the ratio of the Value added (current US$) in Manufacturing in 2005 to that in 2008?
Keep it short and to the point. 0.63. What is the ratio of the Value added (current US$) in Services in 2005 to that in 2008?
Offer a terse response. 0.64. What is the ratio of the Value added (current US$) of Agriculture in 2005 to that in 2008?
Offer a terse response. 0.54. What is the ratio of the Value added (current US$) of Industry in 2006 to that in 2007?
Your answer should be very brief. 0.87. What is the ratio of the Value added (current US$) in Manufacturing in 2006 to that in 2007?
Ensure brevity in your answer.  0.82. What is the ratio of the Value added (current US$) in Services in 2006 to that in 2007?
Provide a short and direct response. 0.82. What is the ratio of the Value added (current US$) of Agriculture in 2006 to that in 2007?
Provide a short and direct response. 0.83. What is the ratio of the Value added (current US$) of Industry in 2006 to that in 2008?
Provide a short and direct response. 0.77. What is the ratio of the Value added (current US$) in Manufacturing in 2006 to that in 2008?
Offer a very short reply. 0.72. What is the ratio of the Value added (current US$) in Services in 2006 to that in 2008?
Keep it short and to the point. 0.71. What is the ratio of the Value added (current US$) of Agriculture in 2006 to that in 2008?
Make the answer very short. 0.54. What is the ratio of the Value added (current US$) of Industry in 2007 to that in 2008?
Ensure brevity in your answer.  0.89. What is the ratio of the Value added (current US$) in Manufacturing in 2007 to that in 2008?
Your answer should be very brief. 0.88. What is the ratio of the Value added (current US$) in Services in 2007 to that in 2008?
Provide a succinct answer. 0.87. What is the ratio of the Value added (current US$) in Agriculture in 2007 to that in 2008?
Offer a terse response. 0.66. What is the difference between the highest and the second highest Value added (current US$) of Industry?
Keep it short and to the point. 2.20e+08. What is the difference between the highest and the second highest Value added (current US$) in Manufacturing?
Give a very brief answer. 1.18e+08. What is the difference between the highest and the second highest Value added (current US$) in Services?
Keep it short and to the point. 7.36e+08. What is the difference between the highest and the second highest Value added (current US$) in Agriculture?
Your answer should be compact. 3.89e+08. What is the difference between the highest and the lowest Value added (current US$) in Industry?
Provide a succinct answer. 8.23e+08. What is the difference between the highest and the lowest Value added (current US$) of Manufacturing?
Offer a very short reply. 5.32e+08. What is the difference between the highest and the lowest Value added (current US$) of Services?
Your answer should be very brief. 2.87e+09. What is the difference between the highest and the lowest Value added (current US$) of Agriculture?
Your response must be concise. 5.63e+08. 